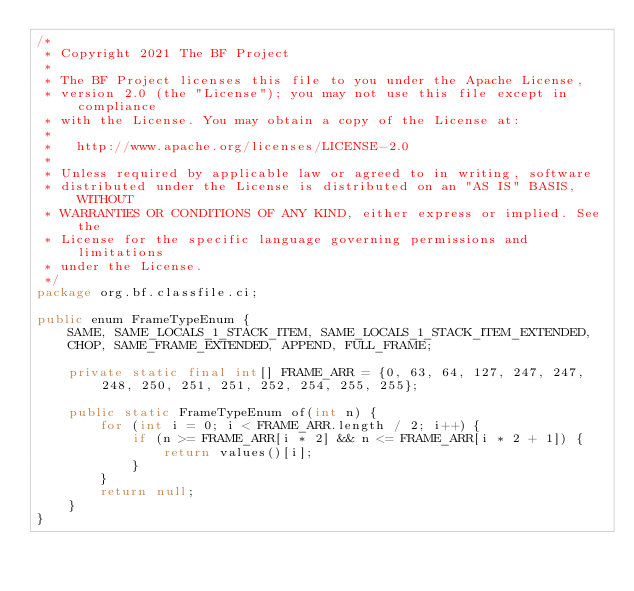Convert code to text. <code><loc_0><loc_0><loc_500><loc_500><_Java_>/*
 * Copyright 2021 The BF Project
 *
 * The BF Project licenses this file to you under the Apache License,
 * version 2.0 (the "License"); you may not use this file except in compliance
 * with the License. You may obtain a copy of the License at:
 *
 *   http://www.apache.org/licenses/LICENSE-2.0
 *
 * Unless required by applicable law or agreed to in writing, software
 * distributed under the License is distributed on an "AS IS" BASIS, WITHOUT
 * WARRANTIES OR CONDITIONS OF ANY KIND, either express or implied. See the
 * License for the specific language governing permissions and limitations
 * under the License.
 */
package org.bf.classfile.ci;

public enum FrameTypeEnum {
    SAME, SAME_LOCALS_1_STACK_ITEM, SAME_LOCALS_1_STACK_ITEM_EXTENDED,
    CHOP, SAME_FRAME_EXTENDED, APPEND, FULL_FRAME;

    private static final int[] FRAME_ARR = {0, 63, 64, 127, 247, 247, 248, 250, 251, 251, 252, 254, 255, 255};

    public static FrameTypeEnum of(int n) {
        for (int i = 0; i < FRAME_ARR.length / 2; i++) {
            if (n >= FRAME_ARR[i * 2] && n <= FRAME_ARR[i * 2 + 1]) {
                return values()[i];
            }
        }
        return null;
    }
}
</code> 